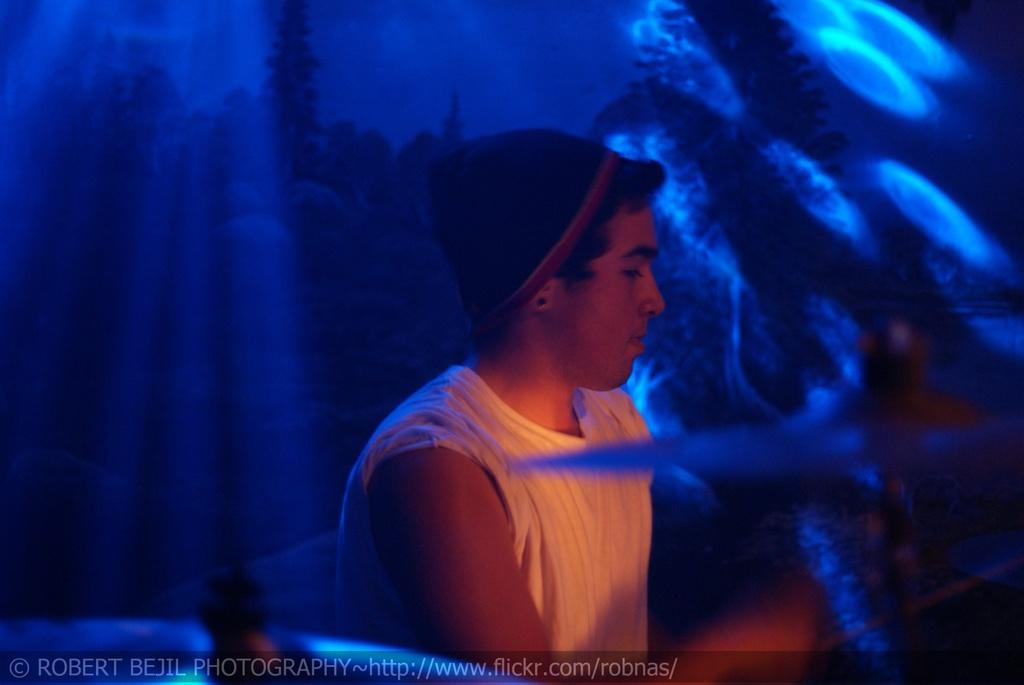Who or what is present in the image? There is a person in the image. What is the person wearing? The person is wearing a white dress. What color is the background of the image? The background of the image is blue. What type of eggnog can be seen in the person's hand in the image? There is no eggnog present in the image; the person is not holding anything. 